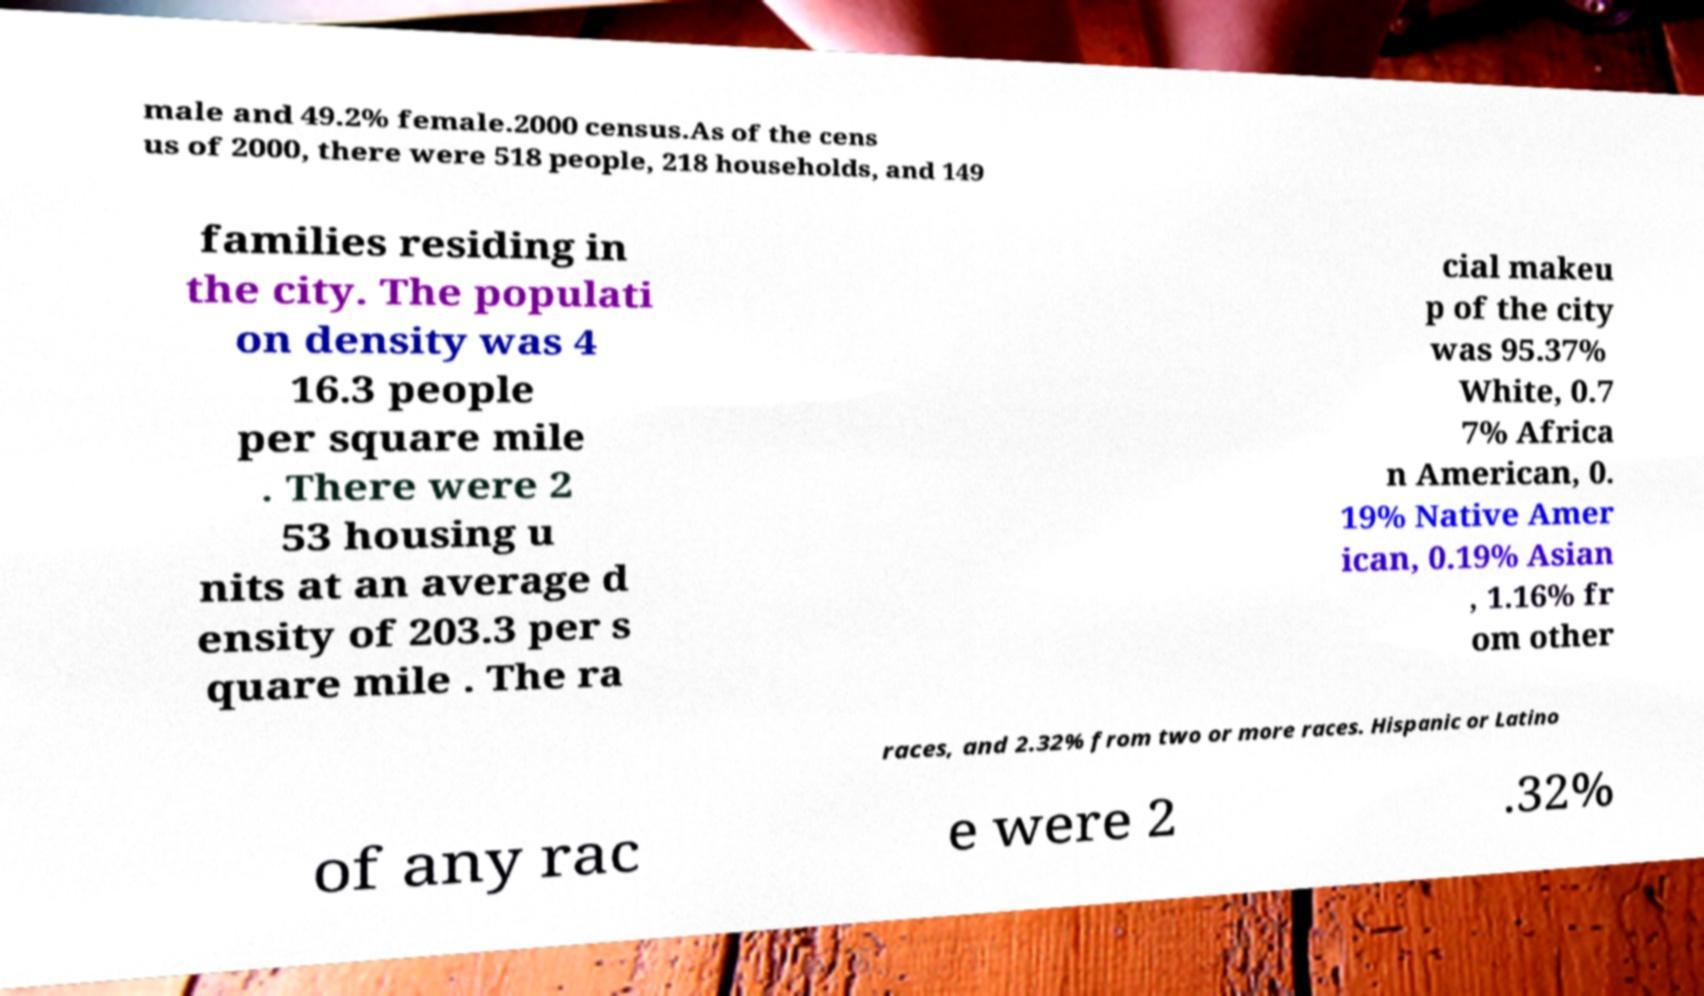Can you accurately transcribe the text from the provided image for me? male and 49.2% female.2000 census.As of the cens us of 2000, there were 518 people, 218 households, and 149 families residing in the city. The populati on density was 4 16.3 people per square mile . There were 2 53 housing u nits at an average d ensity of 203.3 per s quare mile . The ra cial makeu p of the city was 95.37% White, 0.7 7% Africa n American, 0. 19% Native Amer ican, 0.19% Asian , 1.16% fr om other races, and 2.32% from two or more races. Hispanic or Latino of any rac e were 2 .32% 